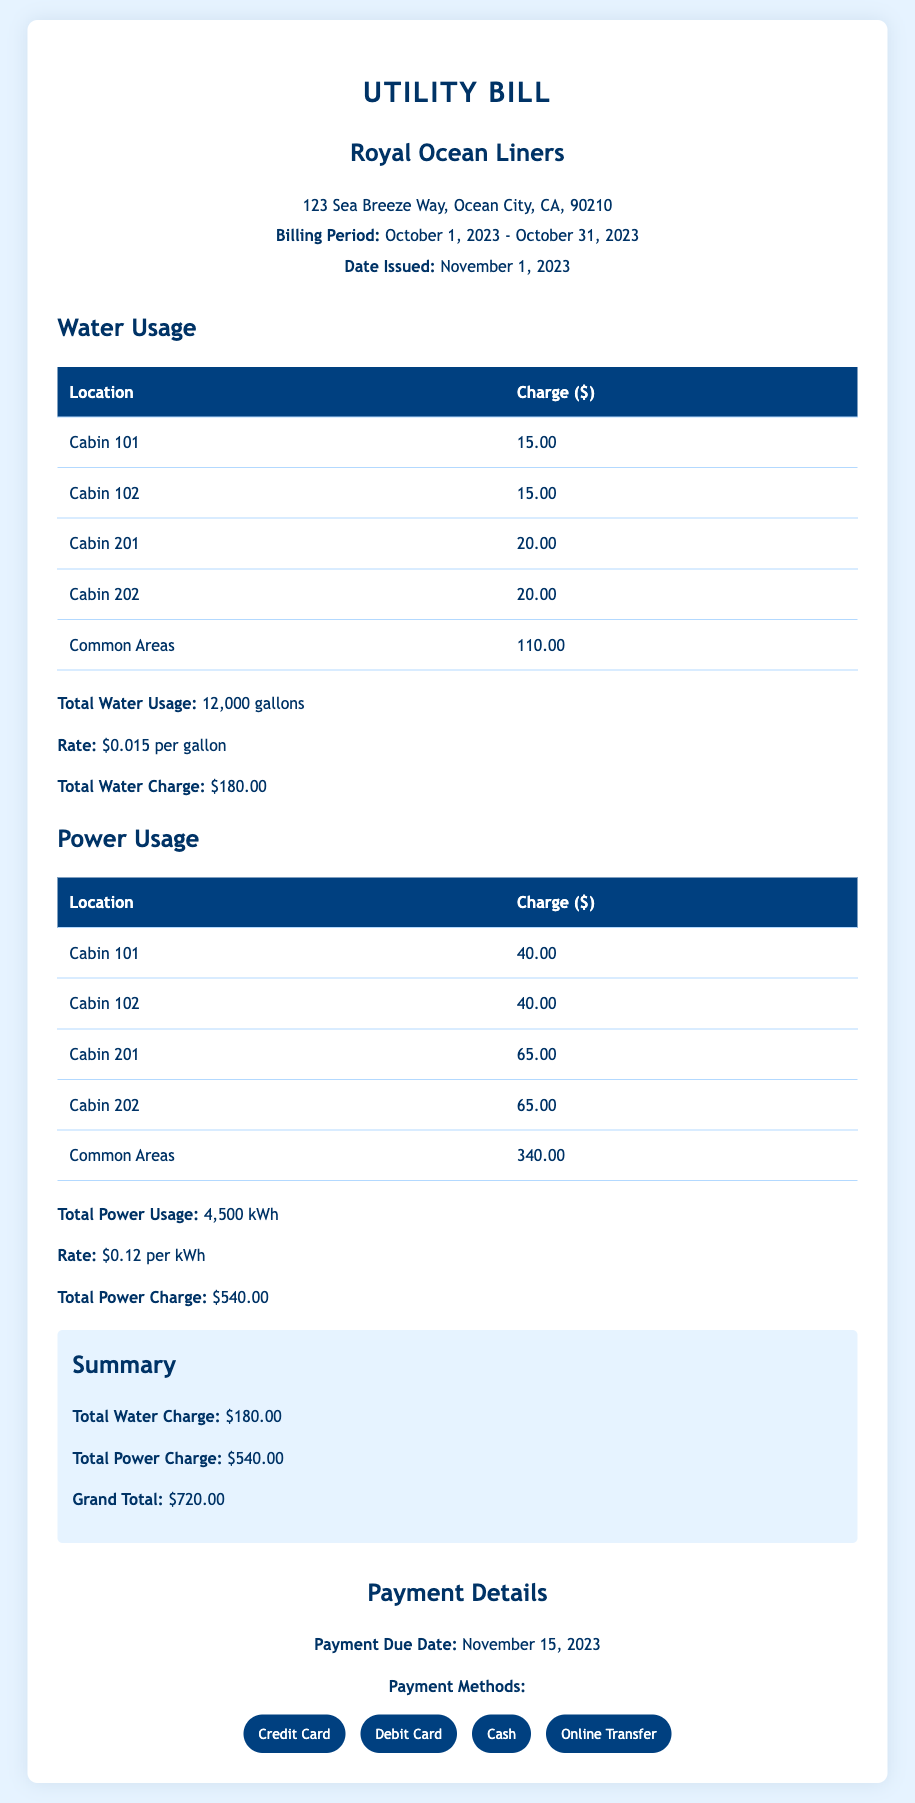What is the billing period? The billing period is clearly stated in the document as October 1, 2023 - October 31, 2023.
Answer: October 1, 2023 - October 31, 2023 What is the total charge for water usage? The total charge for water usage is mentioned in the summary section of the document as $180.00.
Answer: $180.00 Which cabin has the highest power usage charge? Comparing the charges listed, Cabin 201 has the highest charge for power usage at $65.00.
Answer: Cabin 201 What is the total number of gallons used for water? The document specifies the total water usage as 12,000 gallons.
Answer: 12,000 gallons What is the payment due date? The payment due date is explicitly mentioned at the bottom of the document as November 15, 2023.
Answer: November 15, 2023 What is the rate per kWh for power usage? The rate for power usage is mentioned as $0.12 per kWh in the document.
Answer: $0.12 How much did the common areas cost for water usage? The charge for common areas for water usage is stated as $110.00 in the table.
Answer: $110.00 What is the grand total charge for both water and power? The grand total charge is summarized as $720.00 at the end of the document.
Answer: $720.00 Which payment method is NOT listed in the document? The document lists various payment methods, but does not mention check as a payment method.
Answer: Check 